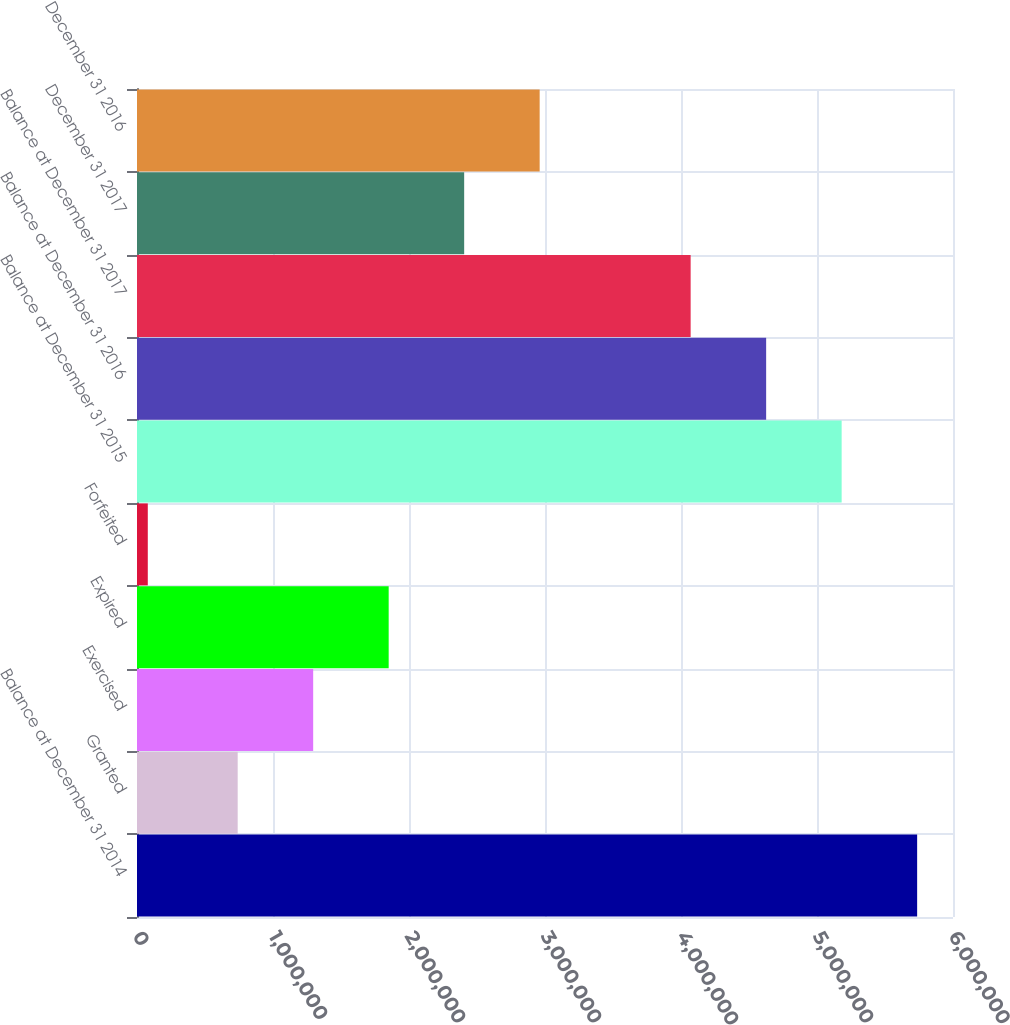Convert chart to OTSL. <chart><loc_0><loc_0><loc_500><loc_500><bar_chart><fcel>Balance at December 31 2014<fcel>Granted<fcel>Exercised<fcel>Expired<fcel>Forfeited<fcel>Balance at December 31 2015<fcel>Balance at December 31 2016<fcel>Balance at December 31 2017<fcel>December 31 2017<fcel>December 31 2016<nl><fcel>5.73633e+06<fcel>740300<fcel>1.29541e+06<fcel>1.85053e+06<fcel>79353<fcel>5.18122e+06<fcel>4.6261e+06<fcel>4.07099e+06<fcel>2.40564e+06<fcel>2.96076e+06<nl></chart> 